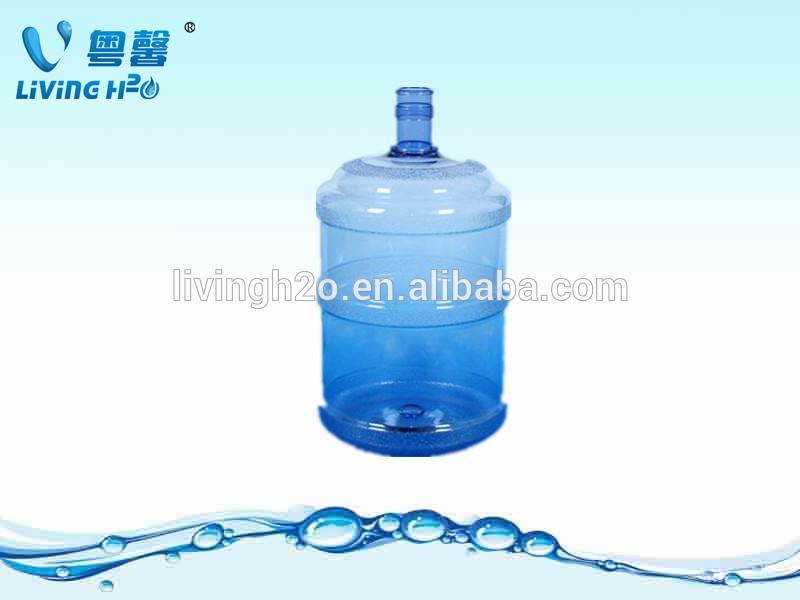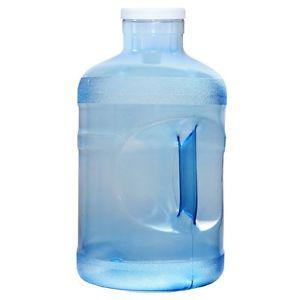The first image is the image on the left, the second image is the image on the right. Evaluate the accuracy of this statement regarding the images: "Each image contains a single upright blue-translucent water jug.". Is it true? Answer yes or no. Yes. The first image is the image on the left, the second image is the image on the right. Assess this claim about the two images: "All images feature a single plastic jug.". Correct or not? Answer yes or no. Yes. 